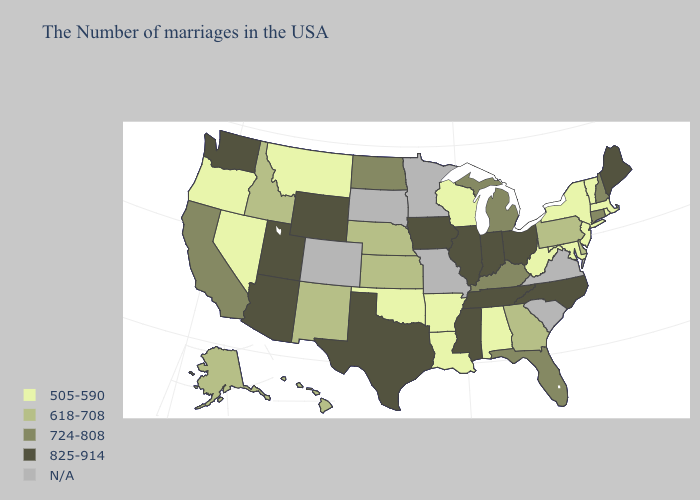What is the value of Kansas?
Write a very short answer. 618-708. Name the states that have a value in the range 724-808?
Quick response, please. New Hampshire, Connecticut, Florida, Michigan, Kentucky, North Dakota, California. What is the lowest value in states that border Oregon?
Keep it brief. 505-590. Name the states that have a value in the range 618-708?
Write a very short answer. Delaware, Pennsylvania, Georgia, Kansas, Nebraska, New Mexico, Idaho, Alaska, Hawaii. Does North Dakota have the highest value in the MidWest?
Answer briefly. No. What is the value of Illinois?
Concise answer only. 825-914. What is the highest value in the USA?
Concise answer only. 825-914. Name the states that have a value in the range N/A?
Give a very brief answer. Virginia, South Carolina, Missouri, Minnesota, South Dakota, Colorado. What is the value of Minnesota?
Write a very short answer. N/A. Among the states that border Wyoming , which have the highest value?
Write a very short answer. Utah. Does Delaware have the highest value in the USA?
Keep it brief. No. What is the lowest value in states that border Arizona?
Short answer required. 505-590. Name the states that have a value in the range 825-914?
Be succinct. Maine, North Carolina, Ohio, Indiana, Tennessee, Illinois, Mississippi, Iowa, Texas, Wyoming, Utah, Arizona, Washington. 